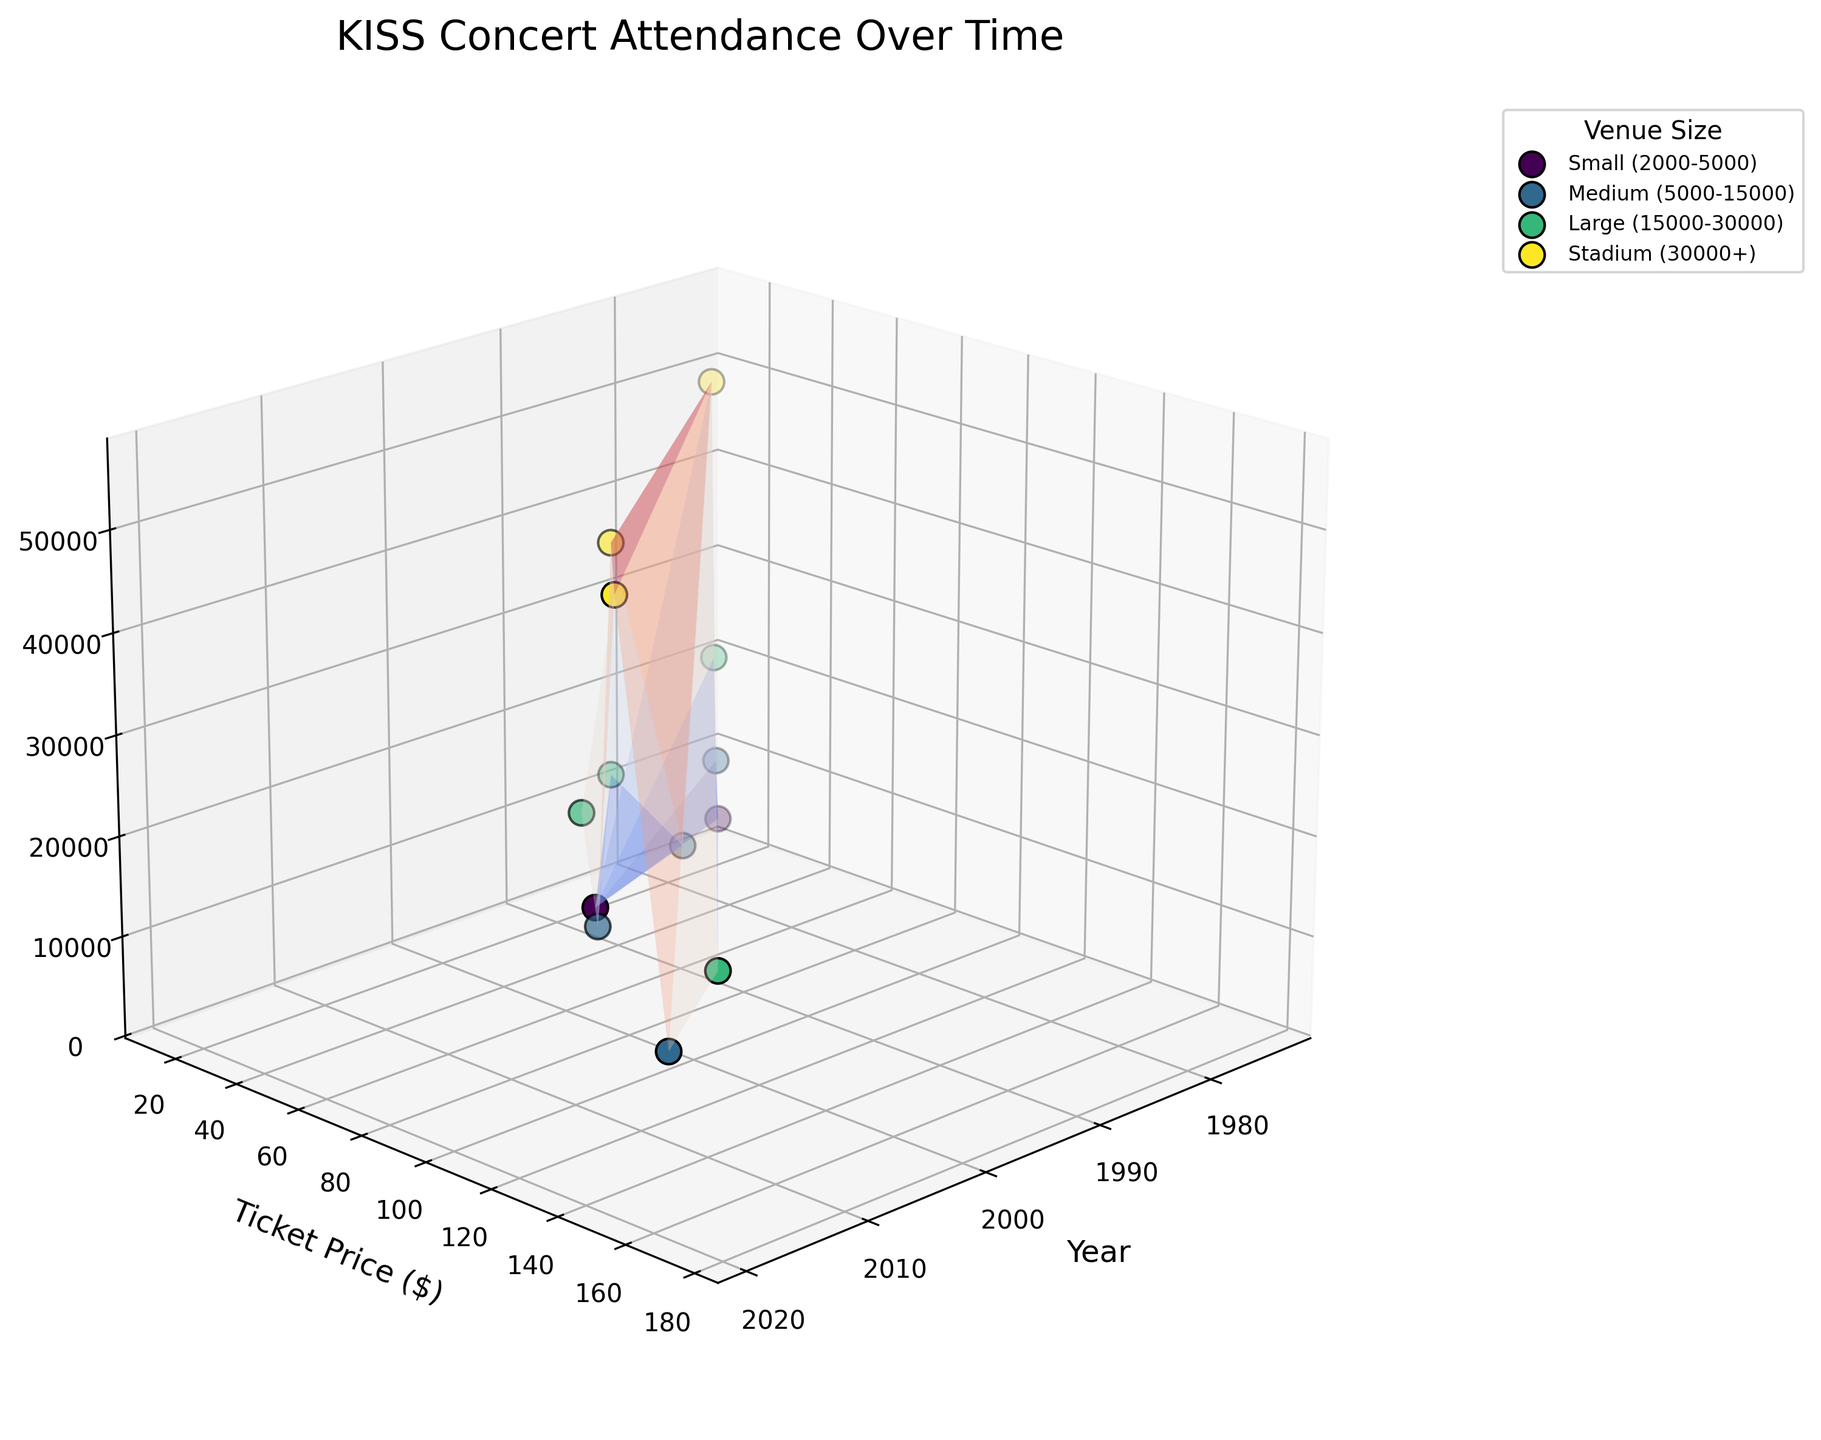What is the title of the figure? The title is located at the top of the figure. It reads 'KISS Concert Attendance Over Time'.
Answer: KISS Concert Attendance Over Time What is the label for the x-axis? The x-axis label is found along the horizontal axis of the 3D plot. It reads 'Year'.
Answer: Year How many venue sizes are represented in the plot? The legend shows the unique venue sizes represented in the plot, counting them yields four types: Small, Medium, Large, and Stadium.
Answer: Four Which year had the highest concert attendance and what was the ticket price? By observing the peaks in the 3D plot along the z-axis for the highest attendance values and then checking the corresponding x (Year) and y (Ticket Price) values, the year 1983 had the highest attendance of 55,000 with a ticket price of $45.
Answer: 1983, $45 Which venue size had the overall lowest attendance in any year and what was it? By examining the lowest points on the z-axis for each venue size, the lowest attendance within a venue was for a Medium venue in 1987, with an attendance of 10,000.
Answer: Medium, 10,000 In which year did a small venue have the highest ticket price and what was the attendance? By looking for the highest y-axis (Ticket Price) value among Small venues shown in the legend and the data points, the year 1992 shows the highest ticket price of $40 with an attendance of 4,500.
Answer: 1992, 4,500 Compare the attendance between medium-sized venues in 1987 and 2016. Which one had higher attendance and by how much? Locate the data points for Medium venues in the years 1987 and 2016 and read off the corresponding z-axis (Attendance). The attendance values are 10,000 in 1987 and 14,000 in 2016. Thus, 2016 had a higher attendance by 4,000.
Answer: 2016, 4,000 What's the trend in ticket prices for stadium concerts over the years presented in the figure? Observing the ticket price values (y-axis) for the data points labeled as 'Stadium' in the legend, the trend shows increasing ticket prices over the years: 1974 ($15), 1983 ($45), 2000 ($75), and 2012 ($120).
Answer: Increasing Which data point represents the earliest year and what are its attributes (year, venue size, ticket price, and attendance)? By finding the earliest year on the x-axis, the data point corresponding to 1974 represents a Small venue, ticket price $15, and attendance of 3,500.
Answer: 1974, Small, $15, 3,500 Does the 3D surface plot indicate any apparent correlation between ticket price and attendance? By examining the overall shape and characteristics of the surface, it appears that as ticket prices (y-axis) increase, attendance (z-axis) typically shows a slight decreasing trend, indicating an inverse correlation on a broader scale, with some variations.
Answer: Inverse correlation 